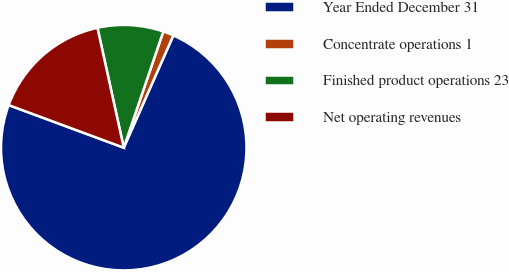<chart> <loc_0><loc_0><loc_500><loc_500><pie_chart><fcel>Year Ended December 31<fcel>Concentrate operations 1<fcel>Finished product operations 23<fcel>Net operating revenues<nl><fcel>74.02%<fcel>1.4%<fcel>8.66%<fcel>15.92%<nl></chart> 